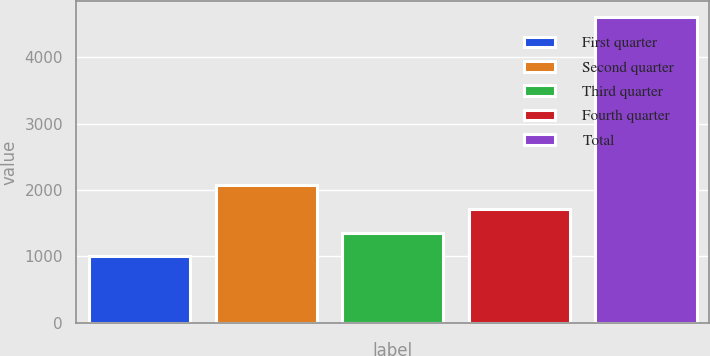<chart> <loc_0><loc_0><loc_500><loc_500><bar_chart><fcel>First quarter<fcel>Second quarter<fcel>Third quarter<fcel>Fourth quarter<fcel>Total<nl><fcel>1000<fcel>2082.1<fcel>1360.7<fcel>1721.4<fcel>4607<nl></chart> 